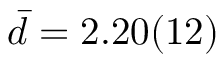Convert formula to latex. <formula><loc_0><loc_0><loc_500><loc_500>\bar { d } = 2 . 2 0 ( 1 2 )</formula> 